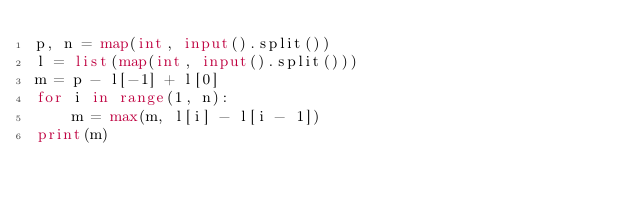Convert code to text. <code><loc_0><loc_0><loc_500><loc_500><_Python_>p, n = map(int, input().split())
l = list(map(int, input().split()))
m = p - l[-1] + l[0]
for i in range(1, n):
    m = max(m, l[i] - l[i - 1])
print(m)
</code> 